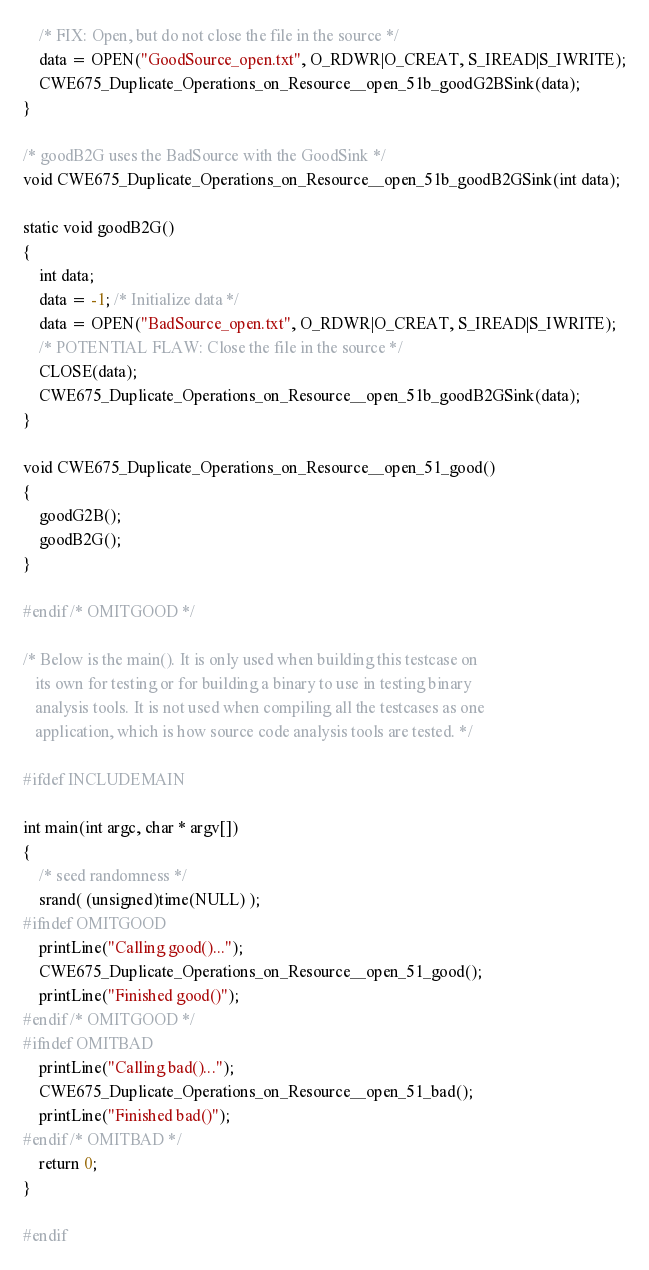Convert code to text. <code><loc_0><loc_0><loc_500><loc_500><_C_>    /* FIX: Open, but do not close the file in the source */
    data = OPEN("GoodSource_open.txt", O_RDWR|O_CREAT, S_IREAD|S_IWRITE);
    CWE675_Duplicate_Operations_on_Resource__open_51b_goodG2BSink(data);
}

/* goodB2G uses the BadSource with the GoodSink */
void CWE675_Duplicate_Operations_on_Resource__open_51b_goodB2GSink(int data);

static void goodB2G()
{
    int data;
    data = -1; /* Initialize data */
    data = OPEN("BadSource_open.txt", O_RDWR|O_CREAT, S_IREAD|S_IWRITE);
    /* POTENTIAL FLAW: Close the file in the source */
    CLOSE(data);
    CWE675_Duplicate_Operations_on_Resource__open_51b_goodB2GSink(data);
}

void CWE675_Duplicate_Operations_on_Resource__open_51_good()
{
    goodG2B();
    goodB2G();
}

#endif /* OMITGOOD */

/* Below is the main(). It is only used when building this testcase on
   its own for testing or for building a binary to use in testing binary
   analysis tools. It is not used when compiling all the testcases as one
   application, which is how source code analysis tools are tested. */

#ifdef INCLUDEMAIN

int main(int argc, char * argv[])
{
    /* seed randomness */
    srand( (unsigned)time(NULL) );
#ifndef OMITGOOD
    printLine("Calling good()...");
    CWE675_Duplicate_Operations_on_Resource__open_51_good();
    printLine("Finished good()");
#endif /* OMITGOOD */
#ifndef OMITBAD
    printLine("Calling bad()...");
    CWE675_Duplicate_Operations_on_Resource__open_51_bad();
    printLine("Finished bad()");
#endif /* OMITBAD */
    return 0;
}

#endif
</code> 